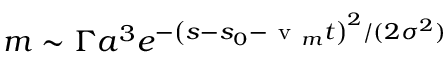Convert formula to latex. <formula><loc_0><loc_0><loc_500><loc_500>m \sim \Gamma a ^ { 3 } e ^ { - \left ( s - s _ { 0 } - v _ { m } t \right ) ^ { 2 } / ( 2 \sigma ^ { 2 } ) }</formula> 